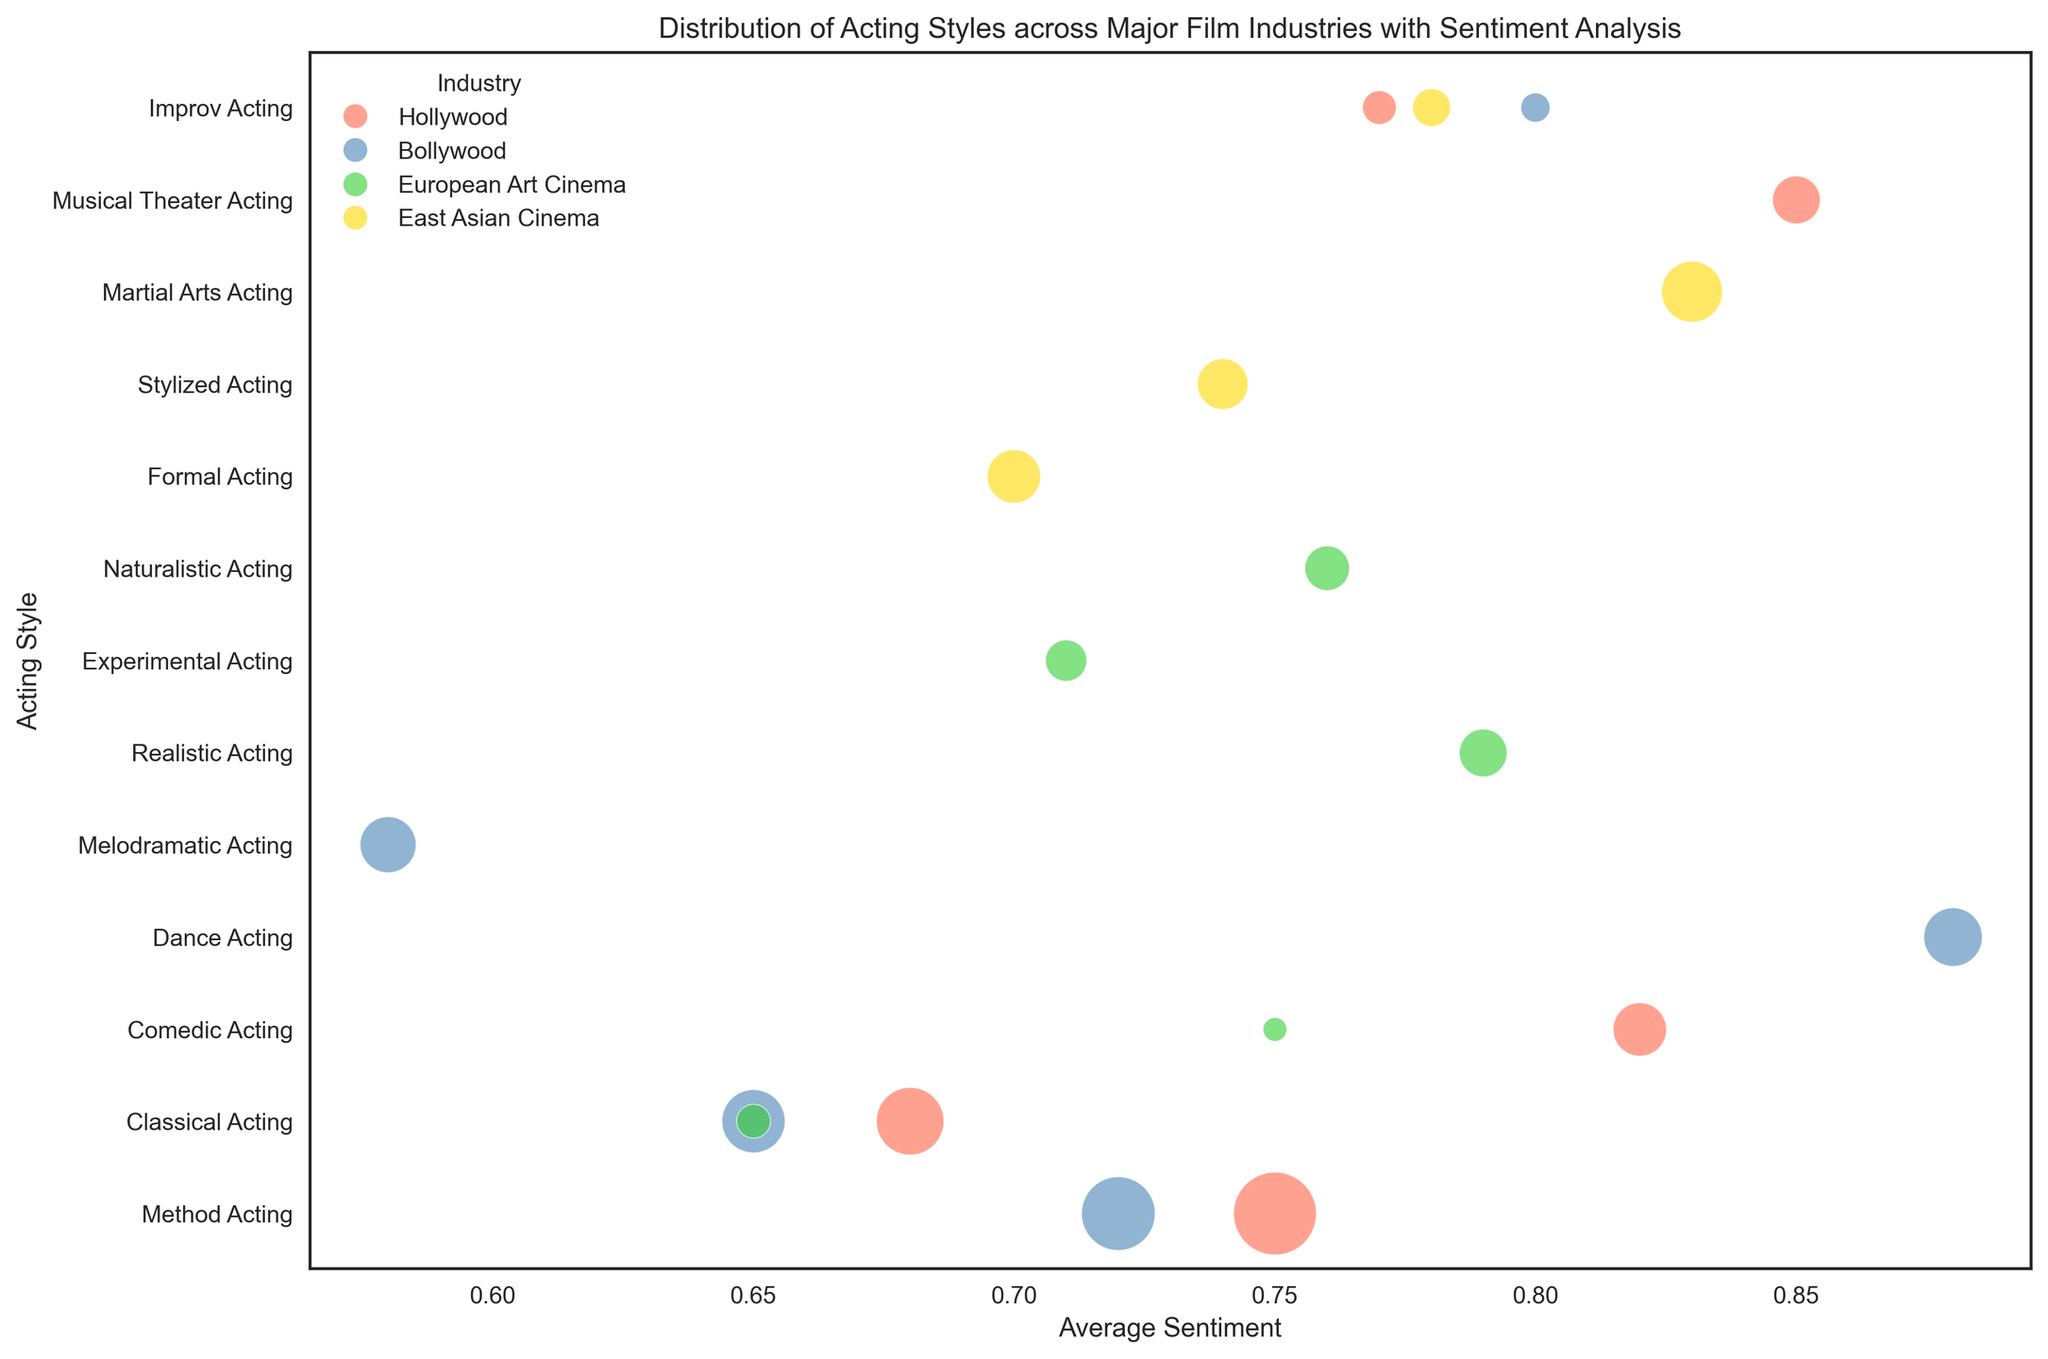What is the most common acting style in Hollywood based on review count? Identify the acting styles for Hollywood and compare their review counts. Method Acting has the highest review count of 120.
Answer: Method Acting Which acting style in Bollywood has the highest average sentiment? Analyze the Bollywood acting styles and their corresponding average sentiment values. Dance Acting has the highest sentiment of 0.88.
Answer: Dance Acting How does the average sentiment of Classical Acting in Hollywood compare to that in European Art Cinema? Check the average sentiment of Classical Acting in both Hollywood and European Art Cinema. Hollywood's sentiment is 0.68 and European Art Cinema's is 0.65. Hollywood's is higher.
Answer: Hollywood's is higher Which industry has the acting style with the lowest average sentiment? Determine the industry and acting style with the lowest average sentiment among all data points. Bollywood's Melodramatic Acting has the lowest sentiment of 0.58.
Answer: Bollywood How many acting styles in East Asian Cinema have an average sentiment above 0.75? Identify the acting styles in East Asian Cinema and count those with sentiments above 0.75. Only Martial Arts Acting has an average sentiment of 0.83.
Answer: 1 Is there an acting style in Bollywood with a higher average sentiment than any style in Hollywood? Compare the highest sentiment value in Bollywood, 0.88 (Dance Acting), with the highest sentiment in Hollywood, 0.85 (Musical Theater Acting). Yes, Bollywood's Dance Acting has a higher sentiment.
Answer: Yes What is the average sentiment value for Method Acting across all industries? Calculate the average sentiment for Method Acting in Hollywood and Bollywood, which are 0.75 and 0.72 respectively. The average is (0.75 + 0.72) / 2 = 0.735.
Answer: 0.735 Which industry has the smallest bubble representing an acting style? Look for the lowest review count, which corresponds to the smallest bubble size. European Art Cinema's Comedic Acting has the smallest bubble with 10 reviews.
Answer: European Art Cinema How does the sentiment for Comedic Acting in Hollywood compare to Comedic Acting in European Art Cinema? Compare the average sentiments for Comedic Acting in Hollywood (0.82) and European Art Cinema (0.75). Hollywood's sentiment is higher.
Answer: Hollywood's is higher What is the total number of reviews for Improv Acting across all industries? Sum up the review counts for Improv Acting in Hollywood (20), Bollywood (15), and East Asian Cinema (25). 20 + 15 + 25 = 60.
Answer: 60 